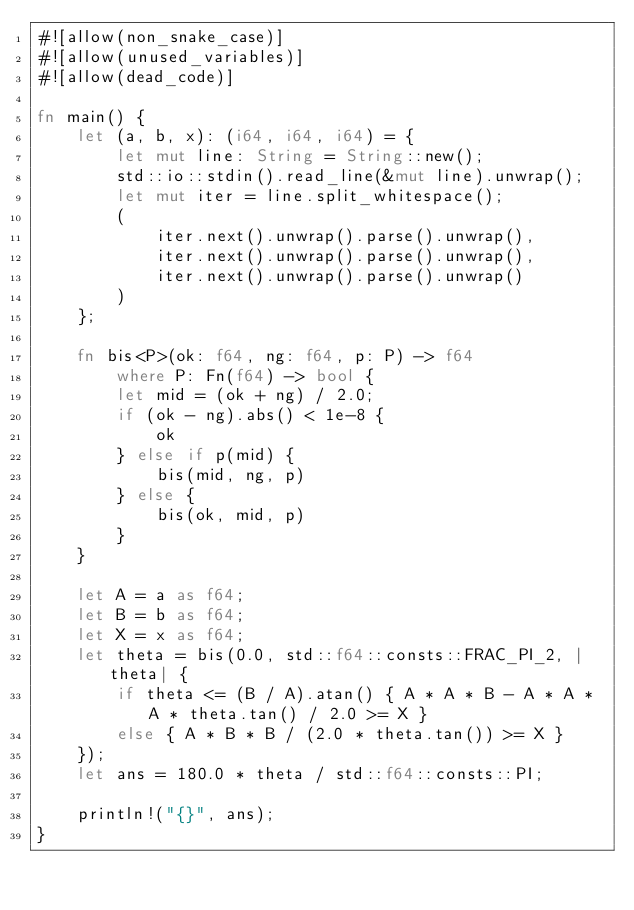<code> <loc_0><loc_0><loc_500><loc_500><_Rust_>#![allow(non_snake_case)]
#![allow(unused_variables)]
#![allow(dead_code)]

fn main() {
    let (a, b, x): (i64, i64, i64) = {
        let mut line: String = String::new();
        std::io::stdin().read_line(&mut line).unwrap();
        let mut iter = line.split_whitespace();
        (
            iter.next().unwrap().parse().unwrap(),
            iter.next().unwrap().parse().unwrap(),
            iter.next().unwrap().parse().unwrap()
        )
    };

    fn bis<P>(ok: f64, ng: f64, p: P) -> f64
        where P: Fn(f64) -> bool {
        let mid = (ok + ng) / 2.0;
        if (ok - ng).abs() < 1e-8 {
            ok
        } else if p(mid) {
            bis(mid, ng, p)
        } else {
            bis(ok, mid, p)
        }
    }

    let A = a as f64;
    let B = b as f64;
    let X = x as f64;
    let theta = bis(0.0, std::f64::consts::FRAC_PI_2, |theta| {
        if theta <= (B / A).atan() { A * A * B - A * A * A * theta.tan() / 2.0 >= X }
        else { A * B * B / (2.0 * theta.tan()) >= X }
    });
    let ans = 180.0 * theta / std::f64::consts::PI;

    println!("{}", ans);
}</code> 